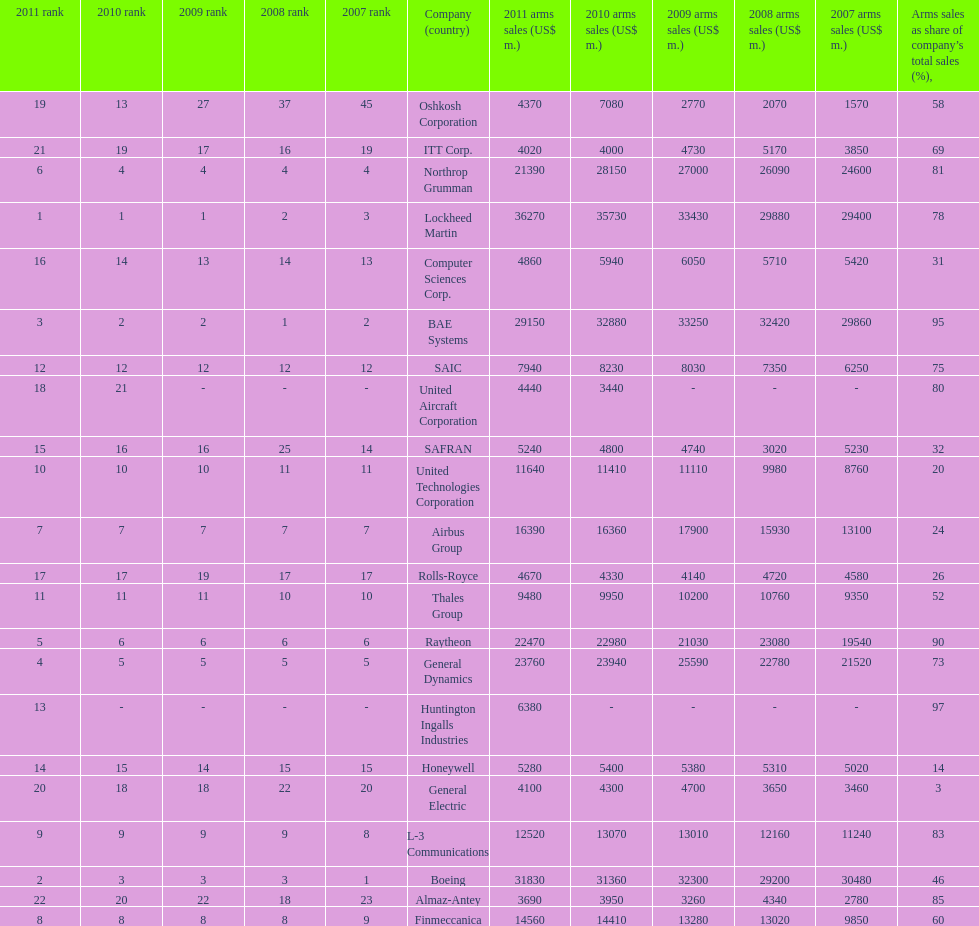Which is the only company to have under 10% arms sales as share of company's total sales? General Electric. 